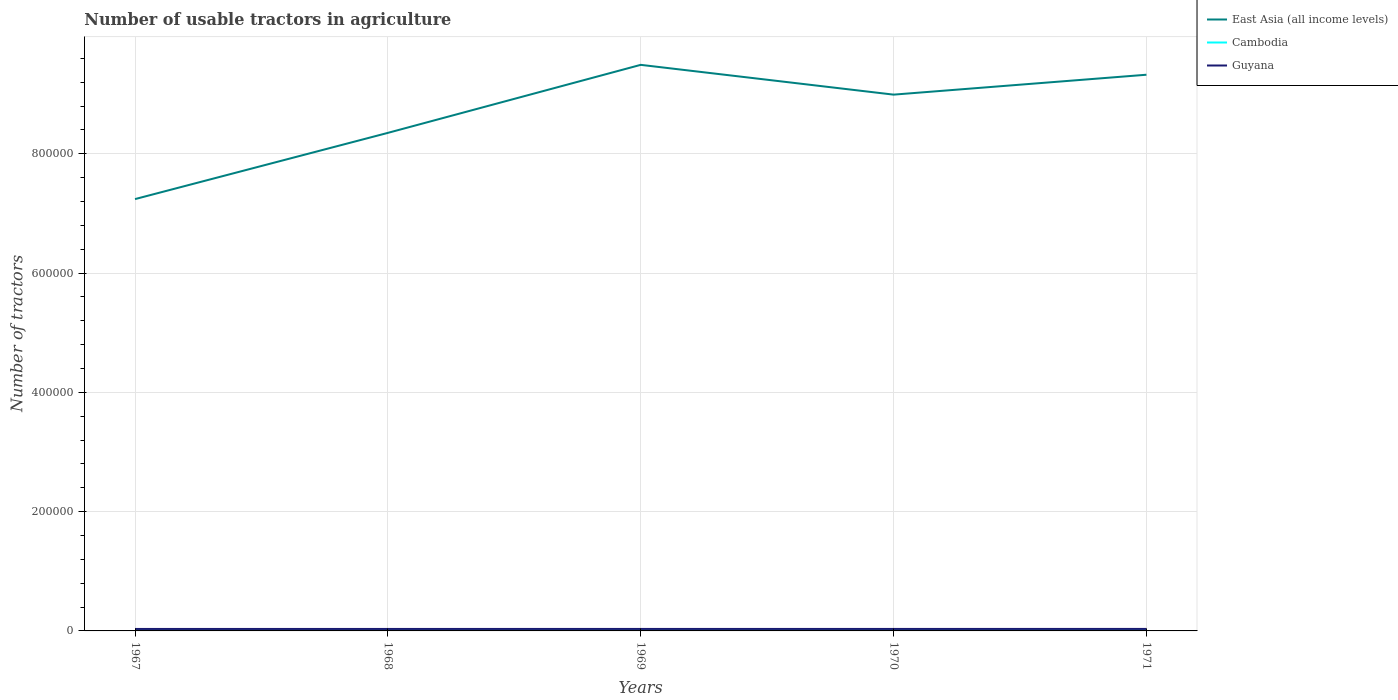How many different coloured lines are there?
Provide a short and direct response. 3. Is the number of lines equal to the number of legend labels?
Keep it short and to the point. Yes. Across all years, what is the maximum number of usable tractors in agriculture in Cambodia?
Keep it short and to the point. 1048. In which year was the number of usable tractors in agriculture in Guyana maximum?
Make the answer very short. 1967. What is the total number of usable tractors in agriculture in East Asia (all income levels) in the graph?
Ensure brevity in your answer.  -1.14e+05. What is the difference between the highest and the second highest number of usable tractors in agriculture in East Asia (all income levels)?
Your answer should be very brief. 2.25e+05. What is the difference between the highest and the lowest number of usable tractors in agriculture in Guyana?
Offer a very short reply. 2. How many lines are there?
Ensure brevity in your answer.  3. What is the difference between two consecutive major ticks on the Y-axis?
Keep it short and to the point. 2.00e+05. Does the graph contain grids?
Your answer should be very brief. Yes. How many legend labels are there?
Provide a short and direct response. 3. What is the title of the graph?
Give a very brief answer. Number of usable tractors in agriculture. Does "Greece" appear as one of the legend labels in the graph?
Your answer should be very brief. No. What is the label or title of the X-axis?
Offer a very short reply. Years. What is the label or title of the Y-axis?
Make the answer very short. Number of tractors. What is the Number of tractors of East Asia (all income levels) in 1967?
Offer a terse response. 7.24e+05. What is the Number of tractors of Cambodia in 1967?
Give a very brief answer. 1048. What is the Number of tractors in Guyana in 1967?
Provide a succinct answer. 3300. What is the Number of tractors of East Asia (all income levels) in 1968?
Your answer should be compact. 8.35e+05. What is the Number of tractors of Cambodia in 1968?
Make the answer very short. 1158. What is the Number of tractors of Guyana in 1968?
Provide a short and direct response. 3310. What is the Number of tractors of East Asia (all income levels) in 1969?
Your response must be concise. 9.49e+05. What is the Number of tractors in Cambodia in 1969?
Your response must be concise. 1233. What is the Number of tractors in Guyana in 1969?
Offer a very short reply. 3320. What is the Number of tractors of East Asia (all income levels) in 1970?
Your answer should be very brief. 8.99e+05. What is the Number of tractors in Cambodia in 1970?
Keep it short and to the point. 1233. What is the Number of tractors of Guyana in 1970?
Ensure brevity in your answer.  3330. What is the Number of tractors in East Asia (all income levels) in 1971?
Your response must be concise. 9.32e+05. What is the Number of tractors in Cambodia in 1971?
Give a very brief answer. 1233. What is the Number of tractors of Guyana in 1971?
Offer a terse response. 3340. Across all years, what is the maximum Number of tractors in East Asia (all income levels)?
Ensure brevity in your answer.  9.49e+05. Across all years, what is the maximum Number of tractors of Cambodia?
Offer a very short reply. 1233. Across all years, what is the maximum Number of tractors of Guyana?
Provide a succinct answer. 3340. Across all years, what is the minimum Number of tractors of East Asia (all income levels)?
Offer a very short reply. 7.24e+05. Across all years, what is the minimum Number of tractors of Cambodia?
Your answer should be compact. 1048. Across all years, what is the minimum Number of tractors in Guyana?
Offer a terse response. 3300. What is the total Number of tractors in East Asia (all income levels) in the graph?
Your answer should be compact. 4.34e+06. What is the total Number of tractors of Cambodia in the graph?
Offer a very short reply. 5905. What is the total Number of tractors of Guyana in the graph?
Ensure brevity in your answer.  1.66e+04. What is the difference between the Number of tractors in East Asia (all income levels) in 1967 and that in 1968?
Your response must be concise. -1.11e+05. What is the difference between the Number of tractors in Cambodia in 1967 and that in 1968?
Provide a succinct answer. -110. What is the difference between the Number of tractors in East Asia (all income levels) in 1967 and that in 1969?
Ensure brevity in your answer.  -2.25e+05. What is the difference between the Number of tractors of Cambodia in 1967 and that in 1969?
Your answer should be very brief. -185. What is the difference between the Number of tractors of Guyana in 1967 and that in 1969?
Your answer should be compact. -20. What is the difference between the Number of tractors of East Asia (all income levels) in 1967 and that in 1970?
Offer a terse response. -1.75e+05. What is the difference between the Number of tractors of Cambodia in 1967 and that in 1970?
Your answer should be compact. -185. What is the difference between the Number of tractors in East Asia (all income levels) in 1967 and that in 1971?
Your answer should be very brief. -2.08e+05. What is the difference between the Number of tractors in Cambodia in 1967 and that in 1971?
Offer a very short reply. -185. What is the difference between the Number of tractors in East Asia (all income levels) in 1968 and that in 1969?
Make the answer very short. -1.14e+05. What is the difference between the Number of tractors of Cambodia in 1968 and that in 1969?
Offer a very short reply. -75. What is the difference between the Number of tractors in East Asia (all income levels) in 1968 and that in 1970?
Your answer should be very brief. -6.41e+04. What is the difference between the Number of tractors of Cambodia in 1968 and that in 1970?
Provide a short and direct response. -75. What is the difference between the Number of tractors of East Asia (all income levels) in 1968 and that in 1971?
Your answer should be very brief. -9.75e+04. What is the difference between the Number of tractors in Cambodia in 1968 and that in 1971?
Provide a succinct answer. -75. What is the difference between the Number of tractors of East Asia (all income levels) in 1969 and that in 1970?
Offer a terse response. 4.99e+04. What is the difference between the Number of tractors of Cambodia in 1969 and that in 1970?
Keep it short and to the point. 0. What is the difference between the Number of tractors in Guyana in 1969 and that in 1970?
Offer a very short reply. -10. What is the difference between the Number of tractors in East Asia (all income levels) in 1969 and that in 1971?
Offer a very short reply. 1.66e+04. What is the difference between the Number of tractors of East Asia (all income levels) in 1970 and that in 1971?
Ensure brevity in your answer.  -3.34e+04. What is the difference between the Number of tractors in Guyana in 1970 and that in 1971?
Your answer should be compact. -10. What is the difference between the Number of tractors in East Asia (all income levels) in 1967 and the Number of tractors in Cambodia in 1968?
Keep it short and to the point. 7.23e+05. What is the difference between the Number of tractors of East Asia (all income levels) in 1967 and the Number of tractors of Guyana in 1968?
Your response must be concise. 7.21e+05. What is the difference between the Number of tractors of Cambodia in 1967 and the Number of tractors of Guyana in 1968?
Your answer should be compact. -2262. What is the difference between the Number of tractors in East Asia (all income levels) in 1967 and the Number of tractors in Cambodia in 1969?
Keep it short and to the point. 7.23e+05. What is the difference between the Number of tractors of East Asia (all income levels) in 1967 and the Number of tractors of Guyana in 1969?
Make the answer very short. 7.21e+05. What is the difference between the Number of tractors in Cambodia in 1967 and the Number of tractors in Guyana in 1969?
Ensure brevity in your answer.  -2272. What is the difference between the Number of tractors in East Asia (all income levels) in 1967 and the Number of tractors in Cambodia in 1970?
Provide a succinct answer. 7.23e+05. What is the difference between the Number of tractors of East Asia (all income levels) in 1967 and the Number of tractors of Guyana in 1970?
Offer a very short reply. 7.21e+05. What is the difference between the Number of tractors in Cambodia in 1967 and the Number of tractors in Guyana in 1970?
Ensure brevity in your answer.  -2282. What is the difference between the Number of tractors in East Asia (all income levels) in 1967 and the Number of tractors in Cambodia in 1971?
Provide a short and direct response. 7.23e+05. What is the difference between the Number of tractors in East Asia (all income levels) in 1967 and the Number of tractors in Guyana in 1971?
Provide a succinct answer. 7.21e+05. What is the difference between the Number of tractors of Cambodia in 1967 and the Number of tractors of Guyana in 1971?
Ensure brevity in your answer.  -2292. What is the difference between the Number of tractors of East Asia (all income levels) in 1968 and the Number of tractors of Cambodia in 1969?
Offer a very short reply. 8.34e+05. What is the difference between the Number of tractors in East Asia (all income levels) in 1968 and the Number of tractors in Guyana in 1969?
Make the answer very short. 8.32e+05. What is the difference between the Number of tractors of Cambodia in 1968 and the Number of tractors of Guyana in 1969?
Ensure brevity in your answer.  -2162. What is the difference between the Number of tractors in East Asia (all income levels) in 1968 and the Number of tractors in Cambodia in 1970?
Offer a terse response. 8.34e+05. What is the difference between the Number of tractors of East Asia (all income levels) in 1968 and the Number of tractors of Guyana in 1970?
Make the answer very short. 8.32e+05. What is the difference between the Number of tractors in Cambodia in 1968 and the Number of tractors in Guyana in 1970?
Your response must be concise. -2172. What is the difference between the Number of tractors in East Asia (all income levels) in 1968 and the Number of tractors in Cambodia in 1971?
Your response must be concise. 8.34e+05. What is the difference between the Number of tractors in East Asia (all income levels) in 1968 and the Number of tractors in Guyana in 1971?
Your answer should be very brief. 8.32e+05. What is the difference between the Number of tractors in Cambodia in 1968 and the Number of tractors in Guyana in 1971?
Make the answer very short. -2182. What is the difference between the Number of tractors of East Asia (all income levels) in 1969 and the Number of tractors of Cambodia in 1970?
Your response must be concise. 9.48e+05. What is the difference between the Number of tractors of East Asia (all income levels) in 1969 and the Number of tractors of Guyana in 1970?
Offer a very short reply. 9.46e+05. What is the difference between the Number of tractors of Cambodia in 1969 and the Number of tractors of Guyana in 1970?
Your response must be concise. -2097. What is the difference between the Number of tractors in East Asia (all income levels) in 1969 and the Number of tractors in Cambodia in 1971?
Provide a short and direct response. 9.48e+05. What is the difference between the Number of tractors of East Asia (all income levels) in 1969 and the Number of tractors of Guyana in 1971?
Make the answer very short. 9.46e+05. What is the difference between the Number of tractors of Cambodia in 1969 and the Number of tractors of Guyana in 1971?
Offer a terse response. -2107. What is the difference between the Number of tractors in East Asia (all income levels) in 1970 and the Number of tractors in Cambodia in 1971?
Offer a very short reply. 8.98e+05. What is the difference between the Number of tractors in East Asia (all income levels) in 1970 and the Number of tractors in Guyana in 1971?
Make the answer very short. 8.96e+05. What is the difference between the Number of tractors in Cambodia in 1970 and the Number of tractors in Guyana in 1971?
Provide a short and direct response. -2107. What is the average Number of tractors of East Asia (all income levels) per year?
Offer a terse response. 8.68e+05. What is the average Number of tractors in Cambodia per year?
Your answer should be compact. 1181. What is the average Number of tractors in Guyana per year?
Ensure brevity in your answer.  3320. In the year 1967, what is the difference between the Number of tractors in East Asia (all income levels) and Number of tractors in Cambodia?
Offer a terse response. 7.23e+05. In the year 1967, what is the difference between the Number of tractors in East Asia (all income levels) and Number of tractors in Guyana?
Give a very brief answer. 7.21e+05. In the year 1967, what is the difference between the Number of tractors of Cambodia and Number of tractors of Guyana?
Offer a terse response. -2252. In the year 1968, what is the difference between the Number of tractors in East Asia (all income levels) and Number of tractors in Cambodia?
Your answer should be very brief. 8.34e+05. In the year 1968, what is the difference between the Number of tractors in East Asia (all income levels) and Number of tractors in Guyana?
Your answer should be compact. 8.32e+05. In the year 1968, what is the difference between the Number of tractors of Cambodia and Number of tractors of Guyana?
Give a very brief answer. -2152. In the year 1969, what is the difference between the Number of tractors of East Asia (all income levels) and Number of tractors of Cambodia?
Your answer should be very brief. 9.48e+05. In the year 1969, what is the difference between the Number of tractors of East Asia (all income levels) and Number of tractors of Guyana?
Provide a succinct answer. 9.46e+05. In the year 1969, what is the difference between the Number of tractors of Cambodia and Number of tractors of Guyana?
Give a very brief answer. -2087. In the year 1970, what is the difference between the Number of tractors of East Asia (all income levels) and Number of tractors of Cambodia?
Your answer should be very brief. 8.98e+05. In the year 1970, what is the difference between the Number of tractors of East Asia (all income levels) and Number of tractors of Guyana?
Your answer should be compact. 8.96e+05. In the year 1970, what is the difference between the Number of tractors of Cambodia and Number of tractors of Guyana?
Offer a terse response. -2097. In the year 1971, what is the difference between the Number of tractors of East Asia (all income levels) and Number of tractors of Cambodia?
Your response must be concise. 9.31e+05. In the year 1971, what is the difference between the Number of tractors in East Asia (all income levels) and Number of tractors in Guyana?
Make the answer very short. 9.29e+05. In the year 1971, what is the difference between the Number of tractors of Cambodia and Number of tractors of Guyana?
Keep it short and to the point. -2107. What is the ratio of the Number of tractors of East Asia (all income levels) in 1967 to that in 1968?
Your answer should be compact. 0.87. What is the ratio of the Number of tractors of Cambodia in 1967 to that in 1968?
Offer a terse response. 0.91. What is the ratio of the Number of tractors of Guyana in 1967 to that in 1968?
Provide a succinct answer. 1. What is the ratio of the Number of tractors in East Asia (all income levels) in 1967 to that in 1969?
Your answer should be very brief. 0.76. What is the ratio of the Number of tractors of Guyana in 1967 to that in 1969?
Offer a very short reply. 0.99. What is the ratio of the Number of tractors of East Asia (all income levels) in 1967 to that in 1970?
Your answer should be very brief. 0.81. What is the ratio of the Number of tractors in Cambodia in 1967 to that in 1970?
Give a very brief answer. 0.85. What is the ratio of the Number of tractors of Guyana in 1967 to that in 1970?
Ensure brevity in your answer.  0.99. What is the ratio of the Number of tractors in East Asia (all income levels) in 1967 to that in 1971?
Ensure brevity in your answer.  0.78. What is the ratio of the Number of tractors of East Asia (all income levels) in 1968 to that in 1969?
Provide a succinct answer. 0.88. What is the ratio of the Number of tractors of Cambodia in 1968 to that in 1969?
Provide a succinct answer. 0.94. What is the ratio of the Number of tractors of East Asia (all income levels) in 1968 to that in 1970?
Ensure brevity in your answer.  0.93. What is the ratio of the Number of tractors of Cambodia in 1968 to that in 1970?
Provide a succinct answer. 0.94. What is the ratio of the Number of tractors of East Asia (all income levels) in 1968 to that in 1971?
Your answer should be compact. 0.9. What is the ratio of the Number of tractors of Cambodia in 1968 to that in 1971?
Provide a short and direct response. 0.94. What is the ratio of the Number of tractors in East Asia (all income levels) in 1969 to that in 1970?
Give a very brief answer. 1.06. What is the ratio of the Number of tractors in East Asia (all income levels) in 1969 to that in 1971?
Give a very brief answer. 1.02. What is the ratio of the Number of tractors of Cambodia in 1969 to that in 1971?
Your response must be concise. 1. What is the ratio of the Number of tractors in East Asia (all income levels) in 1970 to that in 1971?
Your response must be concise. 0.96. What is the ratio of the Number of tractors in Cambodia in 1970 to that in 1971?
Your response must be concise. 1. What is the difference between the highest and the second highest Number of tractors in East Asia (all income levels)?
Keep it short and to the point. 1.66e+04. What is the difference between the highest and the second highest Number of tractors in Guyana?
Offer a very short reply. 10. What is the difference between the highest and the lowest Number of tractors of East Asia (all income levels)?
Your response must be concise. 2.25e+05. What is the difference between the highest and the lowest Number of tractors of Cambodia?
Keep it short and to the point. 185. What is the difference between the highest and the lowest Number of tractors of Guyana?
Offer a terse response. 40. 